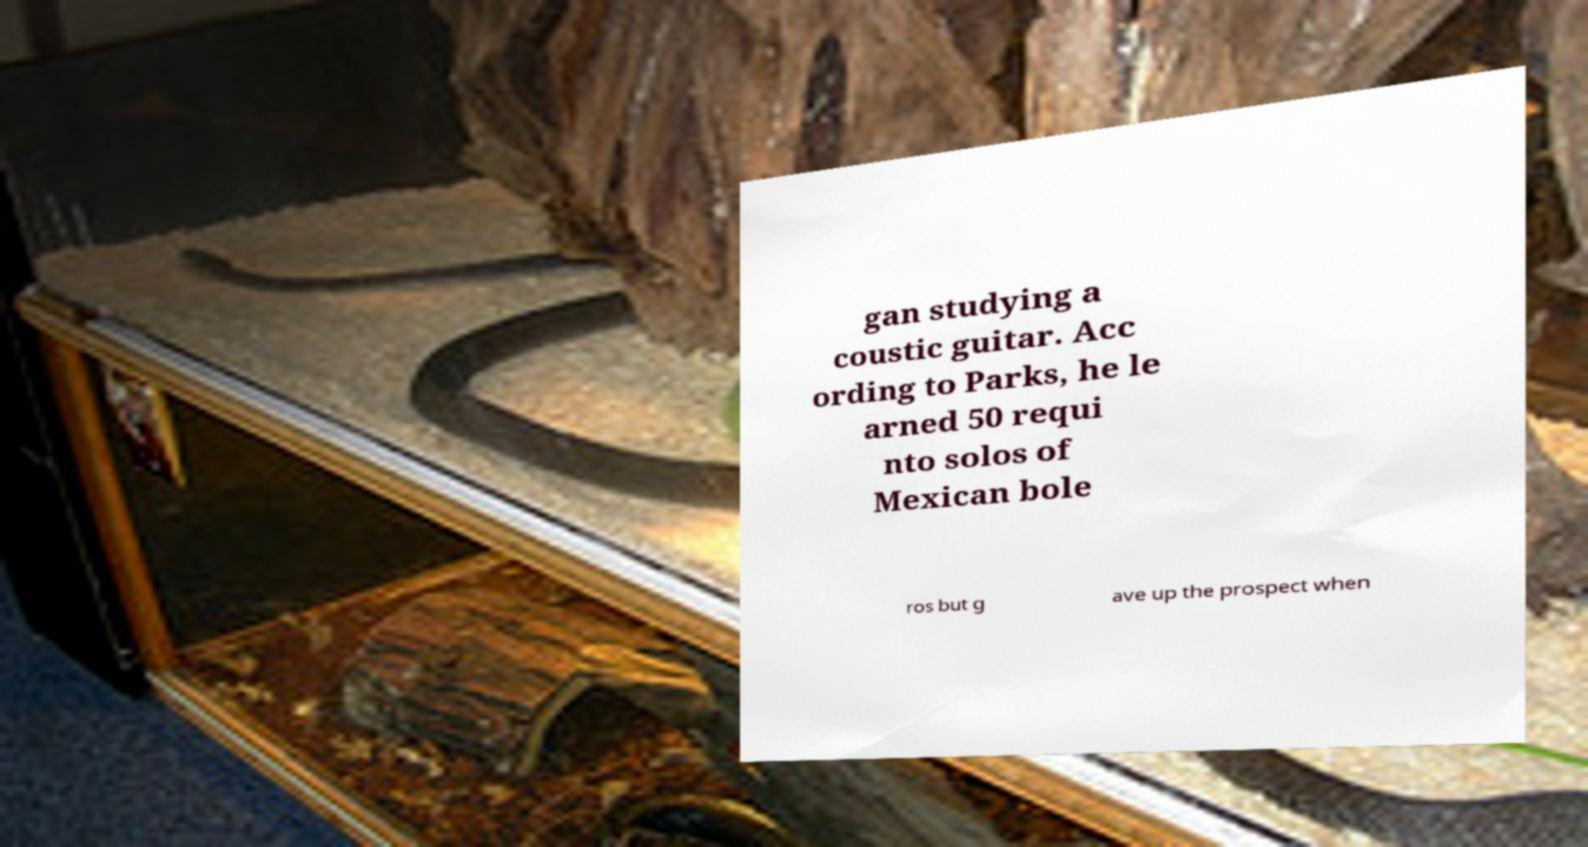What messages or text are displayed in this image? I need them in a readable, typed format. gan studying a coustic guitar. Acc ording to Parks, he le arned 50 requi nto solos of Mexican bole ros but g ave up the prospect when 